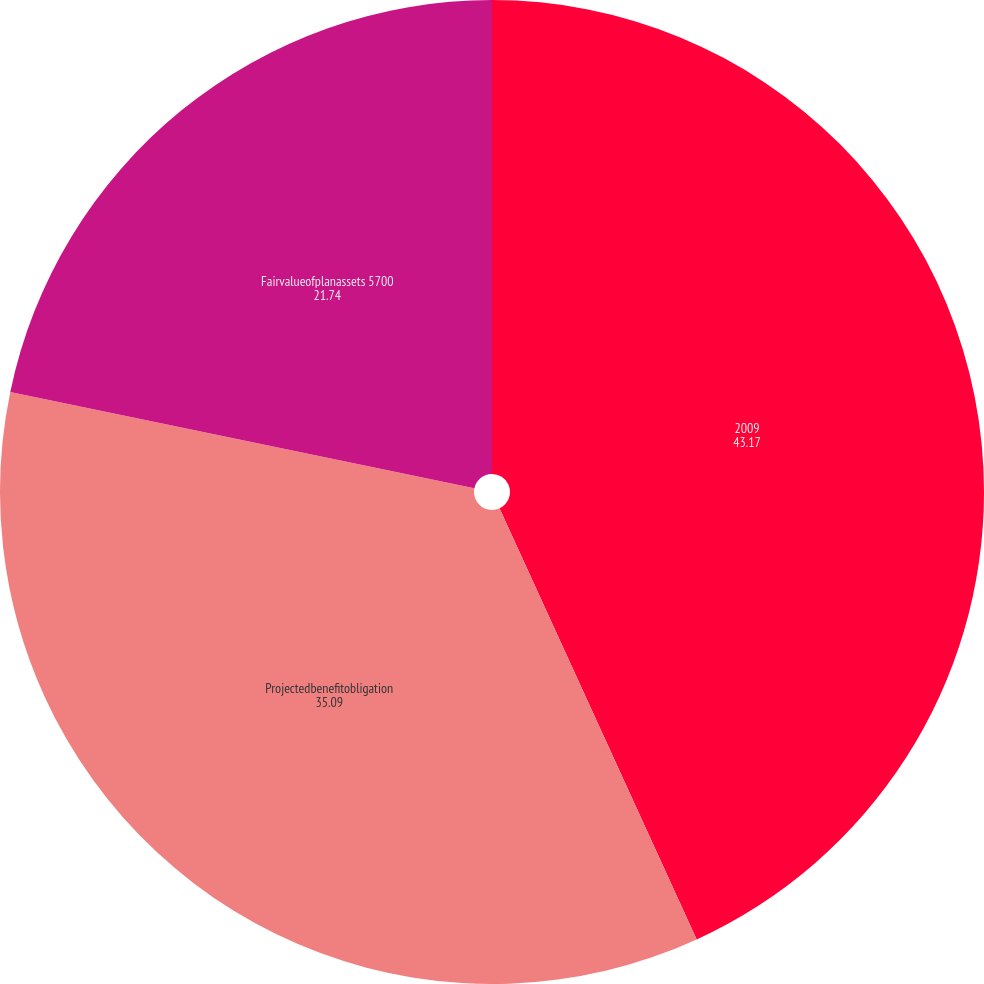<chart> <loc_0><loc_0><loc_500><loc_500><pie_chart><fcel>2009<fcel>Projectedbenefitobligation<fcel>Fairvalueofplanassets 5700<nl><fcel>43.17%<fcel>35.09%<fcel>21.74%<nl></chart> 